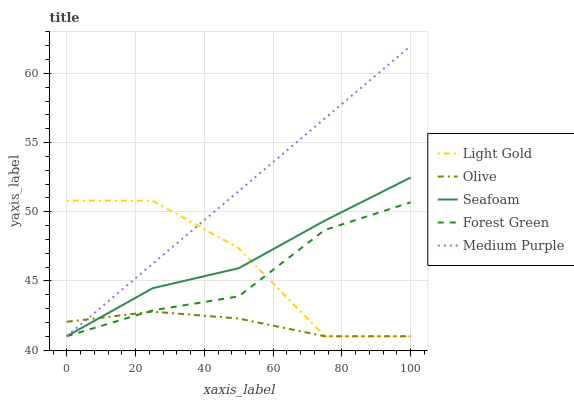Does Olive have the minimum area under the curve?
Answer yes or no. Yes. Does Medium Purple have the maximum area under the curve?
Answer yes or no. Yes. Does Forest Green have the minimum area under the curve?
Answer yes or no. No. Does Forest Green have the maximum area under the curve?
Answer yes or no. No. Is Medium Purple the smoothest?
Answer yes or no. Yes. Is Light Gold the roughest?
Answer yes or no. Yes. Is Forest Green the smoothest?
Answer yes or no. No. Is Forest Green the roughest?
Answer yes or no. No. Does Olive have the lowest value?
Answer yes or no. Yes. Does Medium Purple have the highest value?
Answer yes or no. Yes. Does Forest Green have the highest value?
Answer yes or no. No. Does Olive intersect Light Gold?
Answer yes or no. Yes. Is Olive less than Light Gold?
Answer yes or no. No. Is Olive greater than Light Gold?
Answer yes or no. No. 